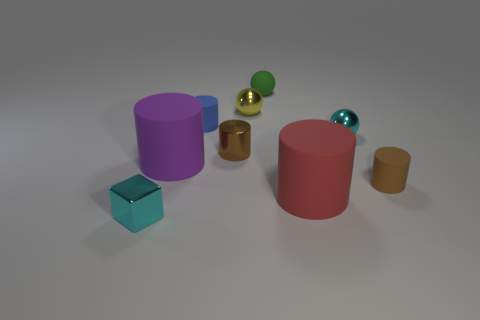Does the brown thing that is right of the small yellow ball have the same shape as the small cyan thing right of the tiny shiny block?
Your answer should be very brief. No. There is a metal object that is the same color as the metal cube; what shape is it?
Keep it short and to the point. Sphere. How many cylinders are made of the same material as the tiny cyan sphere?
Make the answer very short. 1. There is a thing that is in front of the purple object and right of the big red cylinder; what shape is it?
Your answer should be compact. Cylinder. Does the tiny cyan object that is in front of the small brown matte object have the same material as the yellow ball?
Offer a very short reply. Yes. Is there any other thing that has the same material as the yellow sphere?
Your response must be concise. Yes. The thing that is the same size as the red cylinder is what color?
Your answer should be very brief. Purple. Are there any other cylinders that have the same color as the tiny metal cylinder?
Keep it short and to the point. Yes. There is a yellow ball that is the same material as the small cyan block; what size is it?
Make the answer very short. Small. There is a sphere that is the same color as the shiny block; what size is it?
Your response must be concise. Small. 